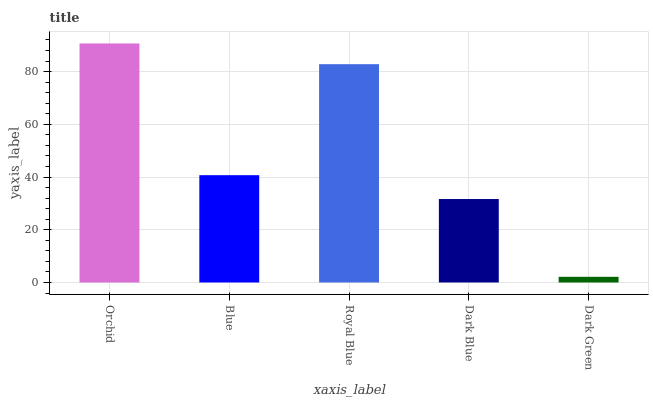Is Blue the minimum?
Answer yes or no. No. Is Blue the maximum?
Answer yes or no. No. Is Orchid greater than Blue?
Answer yes or no. Yes. Is Blue less than Orchid?
Answer yes or no. Yes. Is Blue greater than Orchid?
Answer yes or no. No. Is Orchid less than Blue?
Answer yes or no. No. Is Blue the high median?
Answer yes or no. Yes. Is Blue the low median?
Answer yes or no. Yes. Is Orchid the high median?
Answer yes or no. No. Is Dark Green the low median?
Answer yes or no. No. 